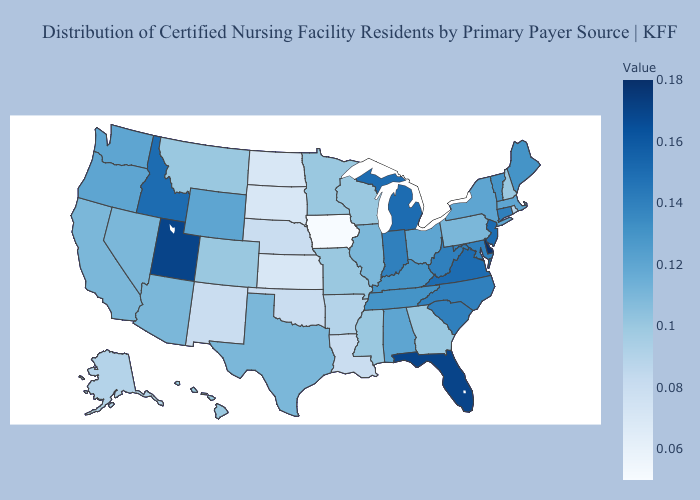Does Alabama have a higher value than Michigan?
Concise answer only. No. Which states have the lowest value in the USA?
Concise answer only. Iowa. Does the map have missing data?
Quick response, please. No. Is the legend a continuous bar?
Write a very short answer. Yes. Which states hav the highest value in the MidWest?
Concise answer only. Michigan. 